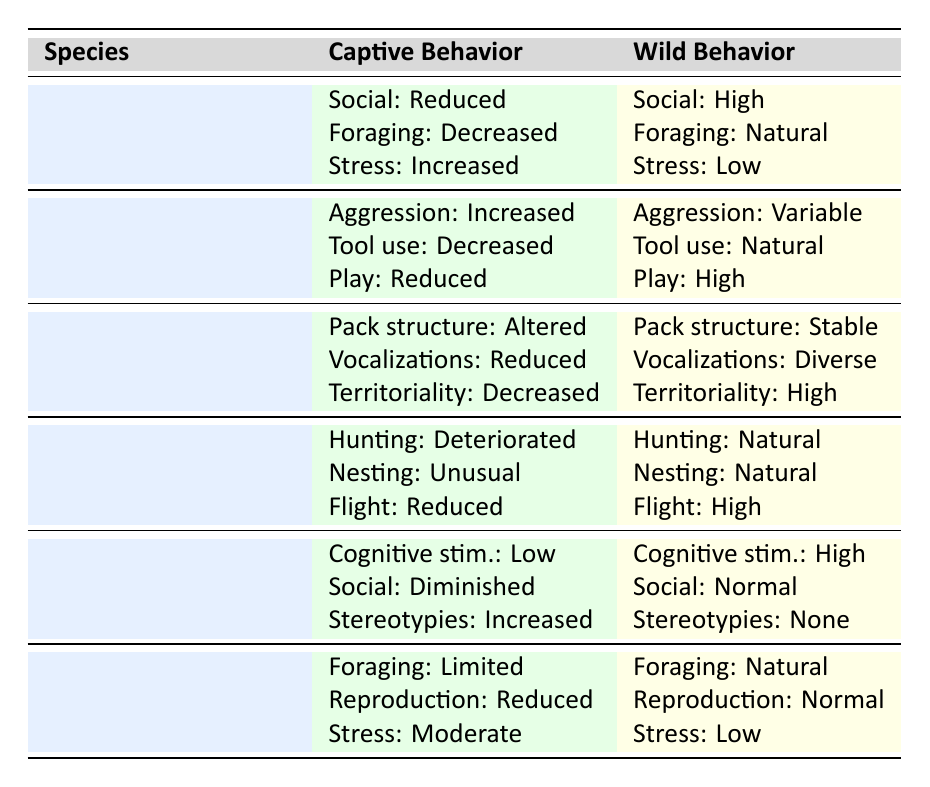What changes occur in the social interaction of the African Elephant in captivity? In the table, under the section for the African Elephant's captive behavior, it states that social interaction is "Reduced." Thus, the change in social interaction is a reduction compared to its wild counterpart, where social interaction is "High."
Answer: Reduced What is the stress level in captive vs. wild Arabian Oryx? For the Arabian Oryx, the captive behavior indicates "Moderate" stress signs while the wild behavior shows "Low" stress signs. This highlights a clear increase in stress levels in captivity compared to the wild.
Answer: Moderate in captivity, Low in wild Which animal shows the greatest duration of captivity and its effect on social interaction? The Orangutan shows the greatest duration of captivity at 20 years. The table lists a "Diminished" level of social interaction in captivity compared to "Normal" social interaction in the wild, revealing a significant detriment in social interaction due to prolonged captivity.
Answer: 20 years, Diminished Is it true that the Bald Eagle's hunting skills deteriorate in captivity? Referring to the table, it clearly states that the Bald Eagle's hunting skills are "Deteriorated" in captivity, confirming that this statement is true.
Answer: Yes What is the average change in vocalizations for both captive Gray Wolves and their wild counterparts? The captive Gray Wolves show "Reduced" vocalizations, while their wild counterparts have "Diverse" vocalizations. Although we cannot assign numeric values for averaging these qualitative descriptions, the noticeable change indicates a significant decrease in vocalization diversity in captivity. Thus, while no numeric average can be calculated, the qualitative assessment suggests a decline.
Answer: Qualitatively decreased How does the captivity duration correlate with stress levels in the species listed? Analyzing the table, we observe multiple species, such as the African Elephant (10 years, Increased stress), Chimpanzee (15 years, Increased aggression), and Arabian Oryx (5 years, Moderate stress). It seems captivity duration correlates with increased stress/behavioral issues, particularly in longer durations such as with the Orangutan (20 years, Increased stereotypies). Therefore, as the captivity duration increases, behavioral changes indicate a correlation with increased stress levels.
Answer: Correlation exists, increased stress with longer durations How does the reproductive behavior of the Arabian Oryx change in captivity? In the table, captive Arabian Oryx show "Reduced" reproductive behavior, while their wild counterparts exhibit "Normal" reproductive behavior, indicating a decline in reproductive activities due to captivity.
Answer: Reduced What are the differences in play behavior between captive Common Chimpanzees and their wild counterparts? The table indicates that captive Common Chimpanzees have "Reduced" play behavior, while their wild counterparts experience "High" play behavior, representing a noticeable decrease in playful activities due to captivity.
Answer: Reduced What behaviors are affected in the captive Gray Wolves, and how does it compare to wild behaviors? The Gray Wolves in captivity have altered pack structure, reduced vocalizations, and decreased territoriality. In contrast, wild behaviors reflect a stable pack structure, diverse vocalizations, and high territoriality, illustrating significant behavioral changes in captivity compared to their natural state.
Answer: Pack structure altered, vocalizations reduced, territoriality decreased 